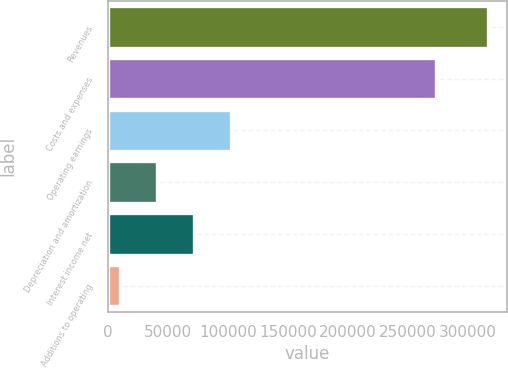Convert chart. <chart><loc_0><loc_0><loc_500><loc_500><bar_chart><fcel>Revenues<fcel>Costs and expenses<fcel>Operating earnings<fcel>Depreciation and amortization<fcel>Interest income net<fcel>Additions to operating<nl><fcel>316934<fcel>273339<fcel>102250<fcel>40912.1<fcel>71581.2<fcel>10243<nl></chart> 